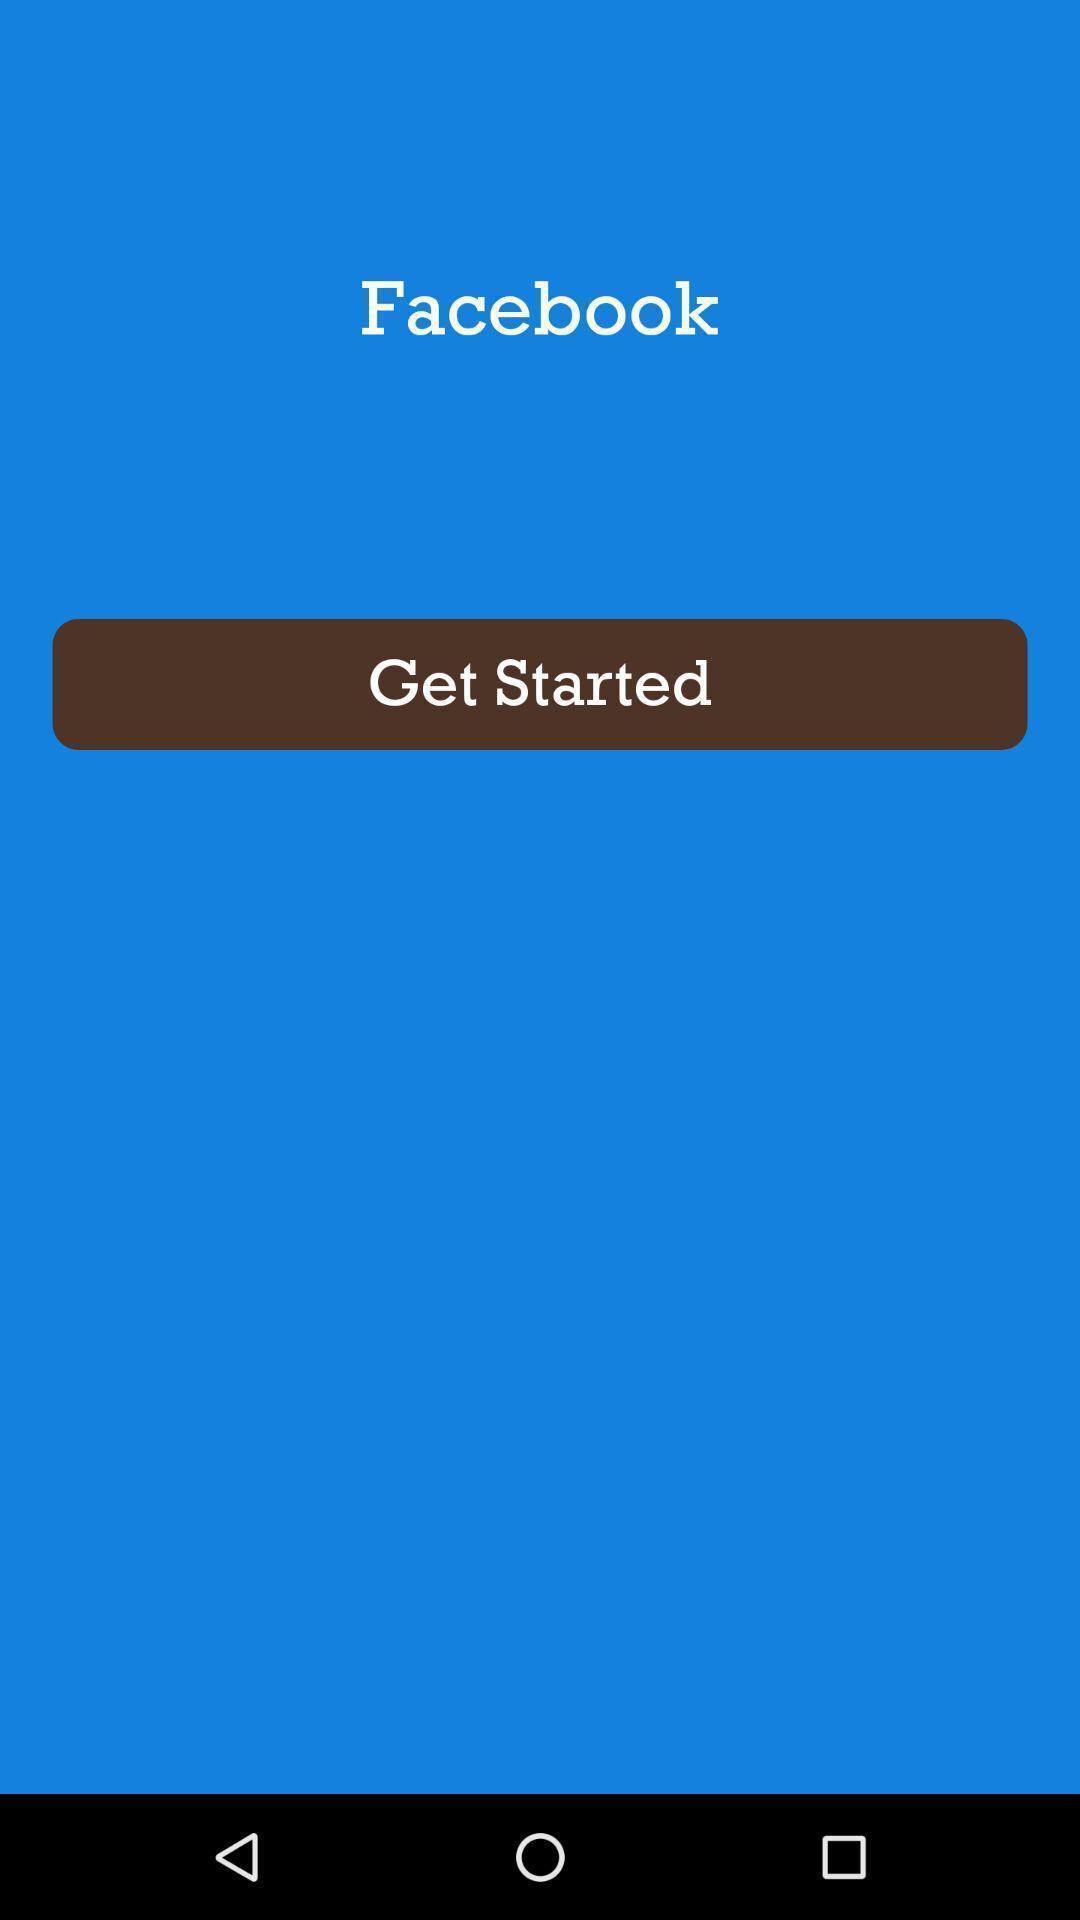What details can you identify in this image? Welcome page of a social application. 